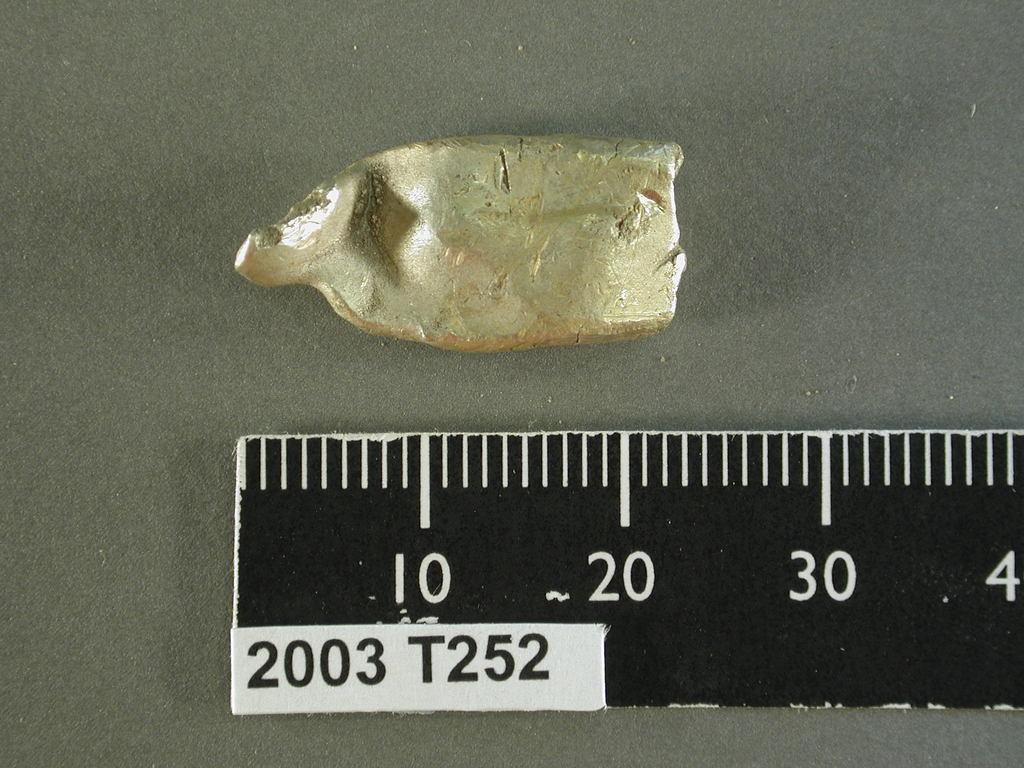<image>
Relay a brief, clear account of the picture shown. The object in the picture appears to be about 23 millimeters long 